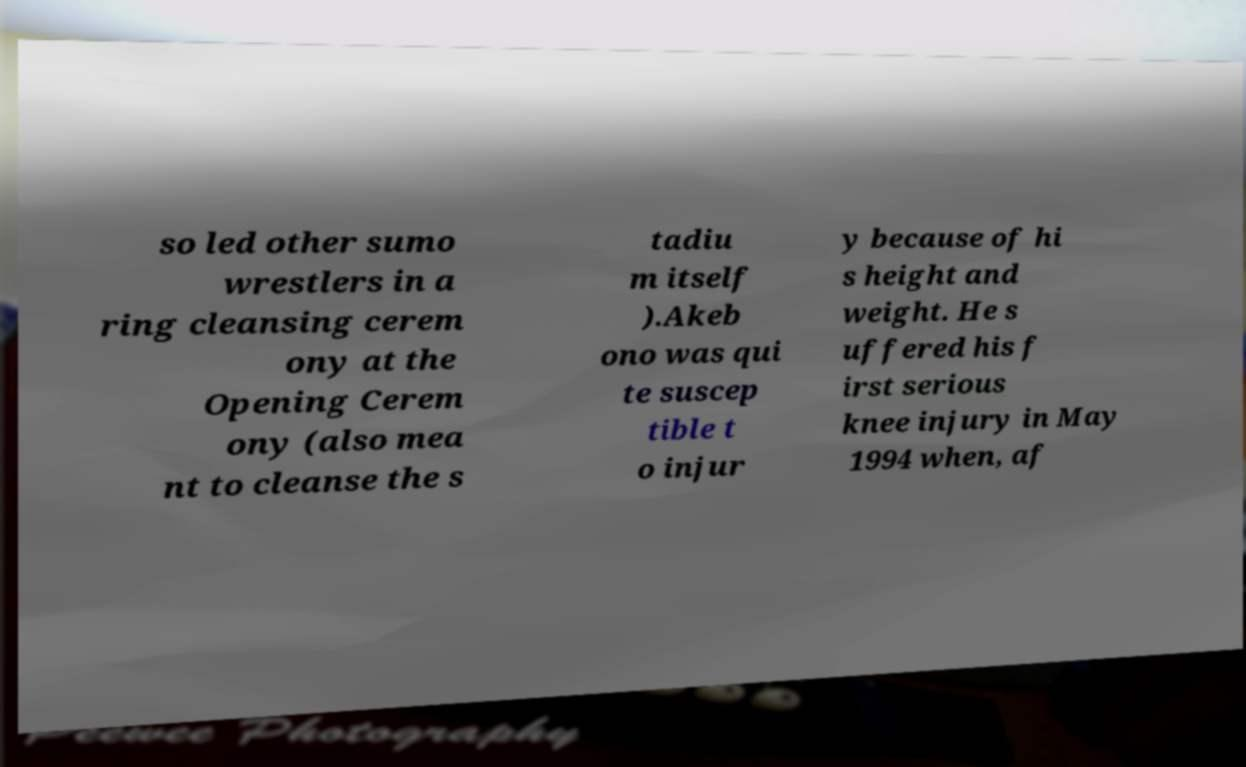Please identify and transcribe the text found in this image. so led other sumo wrestlers in a ring cleansing cerem ony at the Opening Cerem ony (also mea nt to cleanse the s tadiu m itself ).Akeb ono was qui te suscep tible t o injur y because of hi s height and weight. He s uffered his f irst serious knee injury in May 1994 when, af 